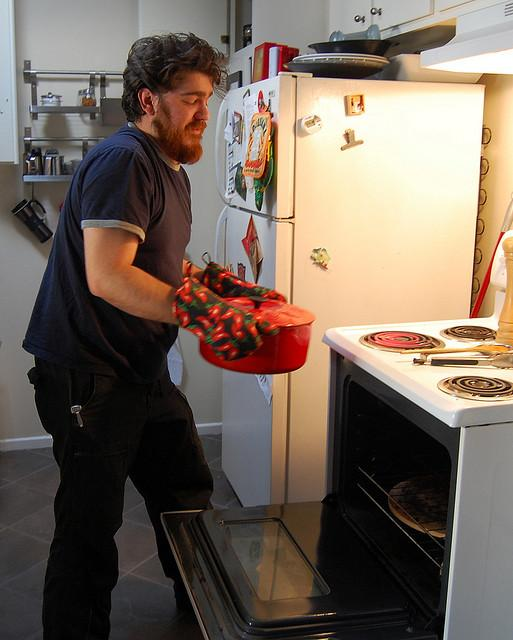What allows him to see the contents of the oven when the door is closed?

Choices:
A) camera
B) magnifying glass
C) window
D) streaming video window 